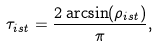<formula> <loc_0><loc_0><loc_500><loc_500>\tau _ { i s t } = \frac { 2 \arcsin ( \rho _ { i s t } ) } { \pi } ,</formula> 